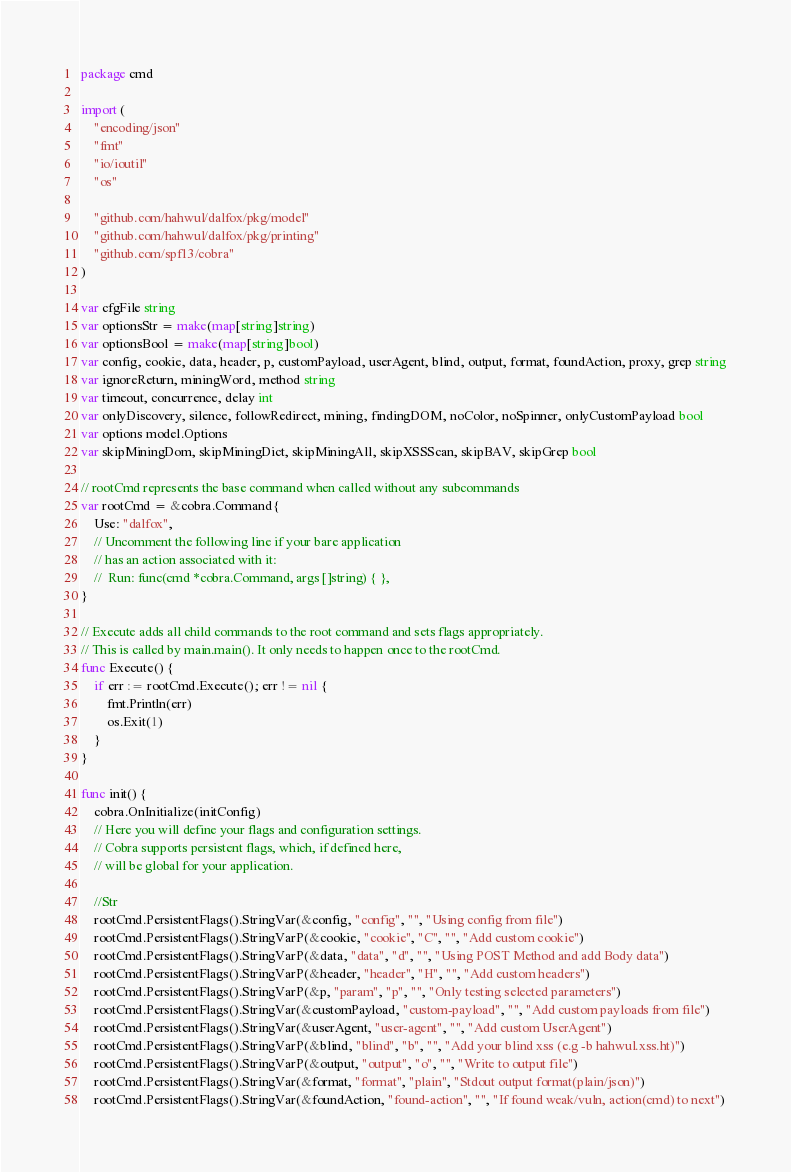<code> <loc_0><loc_0><loc_500><loc_500><_Go_>package cmd

import (
	"encoding/json"
	"fmt"
	"io/ioutil"
	"os"

	"github.com/hahwul/dalfox/pkg/model"
	"github.com/hahwul/dalfox/pkg/printing"
	"github.com/spf13/cobra"
)

var cfgFile string
var optionsStr = make(map[string]string)
var optionsBool = make(map[string]bool)
var config, cookie, data, header, p, customPayload, userAgent, blind, output, format, foundAction, proxy, grep string
var ignoreReturn, miningWord, method string
var timeout, concurrence, delay int
var onlyDiscovery, silence, followRedirect, mining, findingDOM, noColor, noSpinner, onlyCustomPayload bool
var options model.Options
var skipMiningDom, skipMiningDict, skipMiningAll, skipXSSScan, skipBAV, skipGrep bool

// rootCmd represents the base command when called without any subcommands
var rootCmd = &cobra.Command{
	Use: "dalfox",
	// Uncomment the following line if your bare application
	// has an action associated with it:
	//	Run: func(cmd *cobra.Command, args []string) { },
}

// Execute adds all child commands to the root command and sets flags appropriately.
// This is called by main.main(). It only needs to happen once to the rootCmd.
func Execute() {
	if err := rootCmd.Execute(); err != nil {
		fmt.Println(err)
		os.Exit(1)
	}
}

func init() {
	cobra.OnInitialize(initConfig)
	// Here you will define your flags and configuration settings.
	// Cobra supports persistent flags, which, if defined here,
	// will be global for your application.

	//Str
	rootCmd.PersistentFlags().StringVar(&config, "config", "", "Using config from file")
	rootCmd.PersistentFlags().StringVarP(&cookie, "cookie", "C", "", "Add custom cookie")
	rootCmd.PersistentFlags().StringVarP(&data, "data", "d", "", "Using POST Method and add Body data")
	rootCmd.PersistentFlags().StringVarP(&header, "header", "H", "", "Add custom headers")
	rootCmd.PersistentFlags().StringVarP(&p, "param", "p", "", "Only testing selected parameters")
	rootCmd.PersistentFlags().StringVar(&customPayload, "custom-payload", "", "Add custom payloads from file")
	rootCmd.PersistentFlags().StringVar(&userAgent, "user-agent", "", "Add custom UserAgent")
	rootCmd.PersistentFlags().StringVarP(&blind, "blind", "b", "", "Add your blind xss (e.g -b hahwul.xss.ht)")
	rootCmd.PersistentFlags().StringVarP(&output, "output", "o", "", "Write to output file")
	rootCmd.PersistentFlags().StringVar(&format, "format", "plain", "Stdout output format(plain/json)")
	rootCmd.PersistentFlags().StringVar(&foundAction, "found-action", "", "If found weak/vuln, action(cmd) to next")</code> 